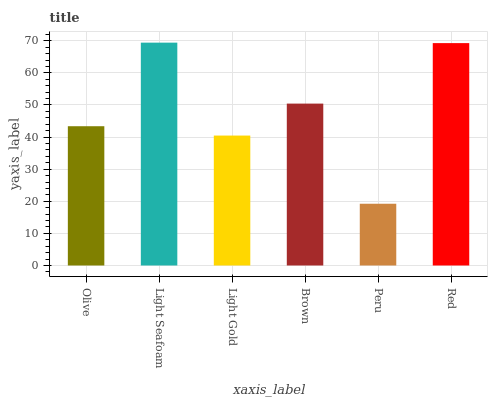Is Peru the minimum?
Answer yes or no. Yes. Is Light Seafoam the maximum?
Answer yes or no. Yes. Is Light Gold the minimum?
Answer yes or no. No. Is Light Gold the maximum?
Answer yes or no. No. Is Light Seafoam greater than Light Gold?
Answer yes or no. Yes. Is Light Gold less than Light Seafoam?
Answer yes or no. Yes. Is Light Gold greater than Light Seafoam?
Answer yes or no. No. Is Light Seafoam less than Light Gold?
Answer yes or no. No. Is Brown the high median?
Answer yes or no. Yes. Is Olive the low median?
Answer yes or no. Yes. Is Light Seafoam the high median?
Answer yes or no. No. Is Brown the low median?
Answer yes or no. No. 